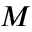<formula> <loc_0><loc_0><loc_500><loc_500>M</formula> 